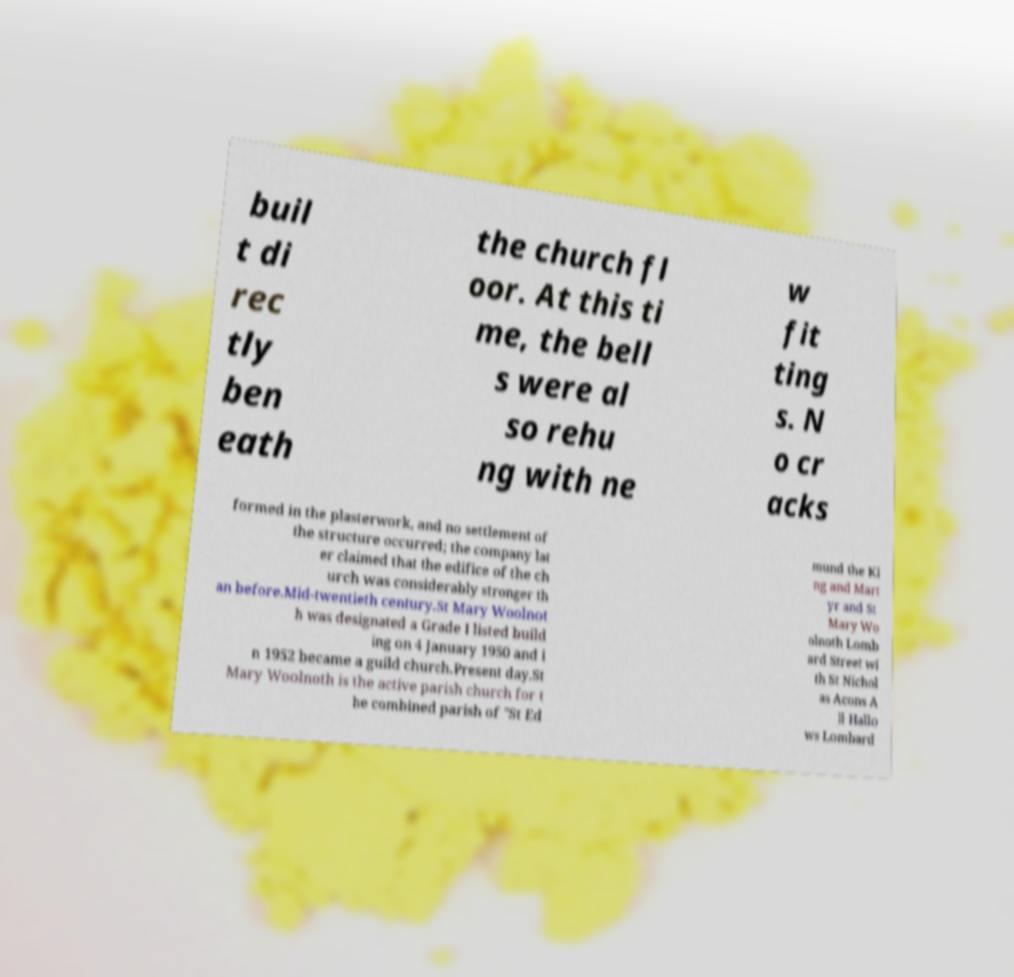Can you read and provide the text displayed in the image?This photo seems to have some interesting text. Can you extract and type it out for me? buil t di rec tly ben eath the church fl oor. At this ti me, the bell s were al so rehu ng with ne w fit ting s. N o cr acks formed in the plasterwork, and no settlement of the structure occurred; the company lat er claimed that the edifice of the ch urch was considerably stronger th an before.Mid-twentieth century.St Mary Woolnot h was designated a Grade I listed build ing on 4 January 1950 and i n 1952 became a guild church.Present day.St Mary Woolnoth is the active parish church for t he combined parish of "St Ed mund the Ki ng and Mart yr and St Mary Wo olnoth Lomb ard Street wi th St Nichol as Acons A ll Hallo ws Lombard 